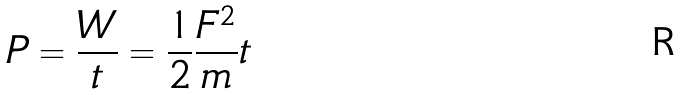Convert formula to latex. <formula><loc_0><loc_0><loc_500><loc_500>P = \frac { W } { t } = \frac { 1 } { 2 } \frac { F ^ { 2 } } { m } t</formula> 